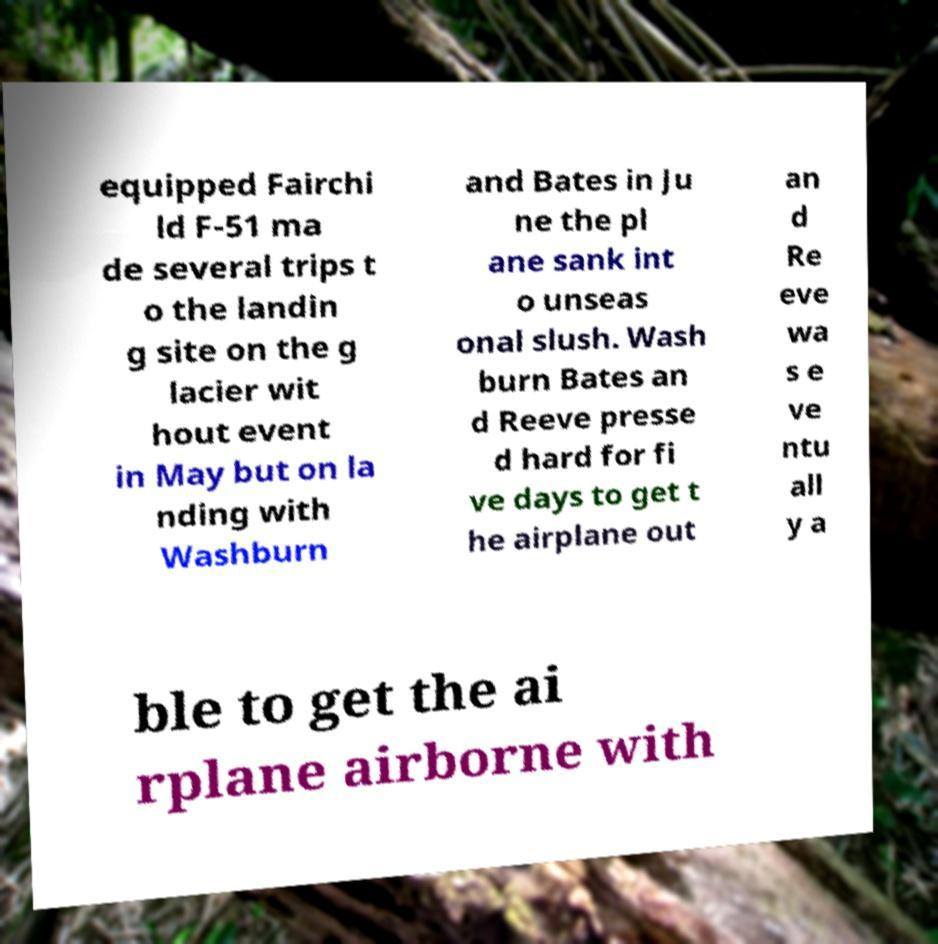There's text embedded in this image that I need extracted. Can you transcribe it verbatim? equipped Fairchi ld F-51 ma de several trips t o the landin g site on the g lacier wit hout event in May but on la nding with Washburn and Bates in Ju ne the pl ane sank int o unseas onal slush. Wash burn Bates an d Reeve presse d hard for fi ve days to get t he airplane out an d Re eve wa s e ve ntu all y a ble to get the ai rplane airborne with 